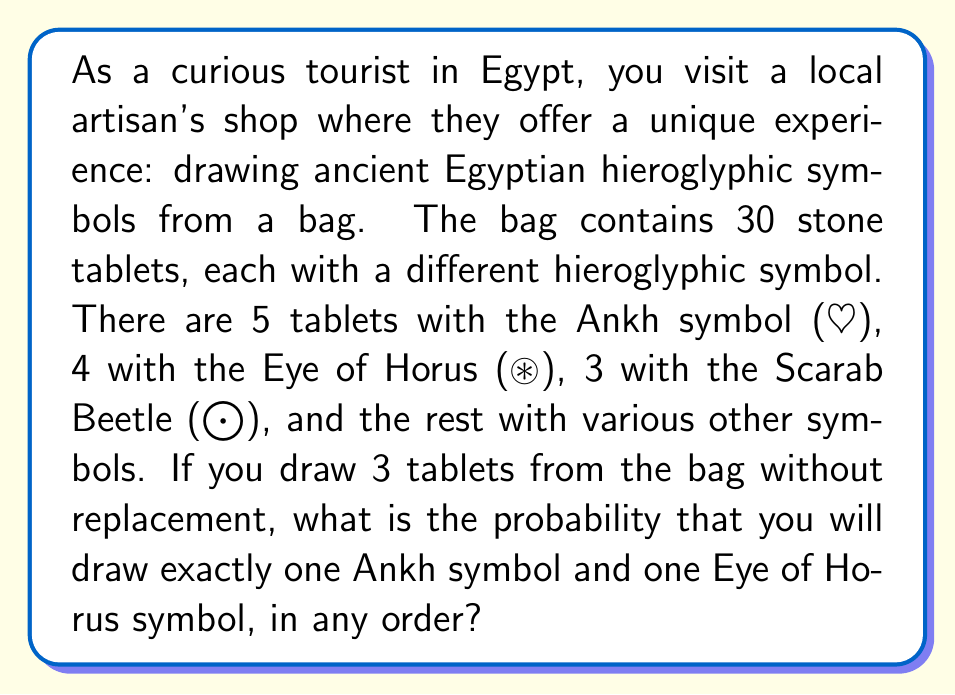Could you help me with this problem? Let's approach this step-by-step:

1) First, we need to calculate the total number of ways to draw 3 tablets from 30. This is given by the combination formula:

   $$\binom{30}{3} = \frac{30!}{3!(30-3)!} = \frac{30!}{3!27!} = 4060$$

2) Now, we need to calculate the number of ways to draw exactly one Ankh, one Eye of Horus, and one other symbol that is neither Ankh nor Eye of Horus. This can be done in the following way:

   - Choose 1 Ankh from 5: $\binom{5}{1}$
   - Choose 1 Eye of Horus from 4: $\binom{4}{1}$
   - Choose 1 other symbol from the remaining 21 (30 - 5 - 4): $\binom{21}{1}$

3) Multiply these together and then by 3! (because the order doesn't matter):

   $$5 \cdot 4 \cdot 21 \cdot 3! = 2520$$

4) The probability is then the number of favorable outcomes divided by the total number of possible outcomes:

   $$P(\text{1 Ankh, 1 Eye of Horus, 1 Other}) = \frac{2520}{4060}$$

5) Simplify the fraction:

   $$\frac{2520}{4060} = \frac{630}{1015} \approx 0.6207$$
Answer: The probability of drawing exactly one Ankh symbol and one Eye of Horus symbol, in any order, when drawing 3 tablets from the bag is $\frac{630}{1015}$ or approximately 0.6207 (62.07%). 